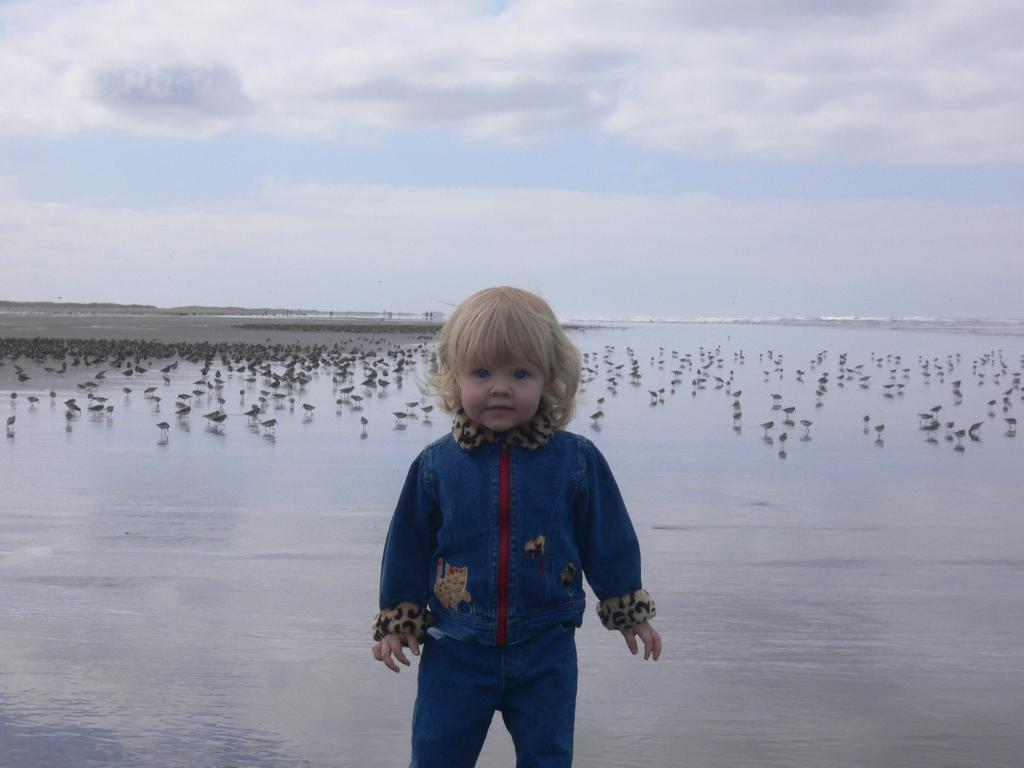What is the main subject of the image? The main subject of the image is a kid standing. What is the kid wearing in the image? The kid is wearing clothes in the image. What can be seen in the water in the image? There are birds in the water in the image. What is visible in the sky in the image? There are clouds in the sky in the image. What type of clover is being discussed by the birds in the image? There is no clover present in the image, nor is there any discussion between the birds. 